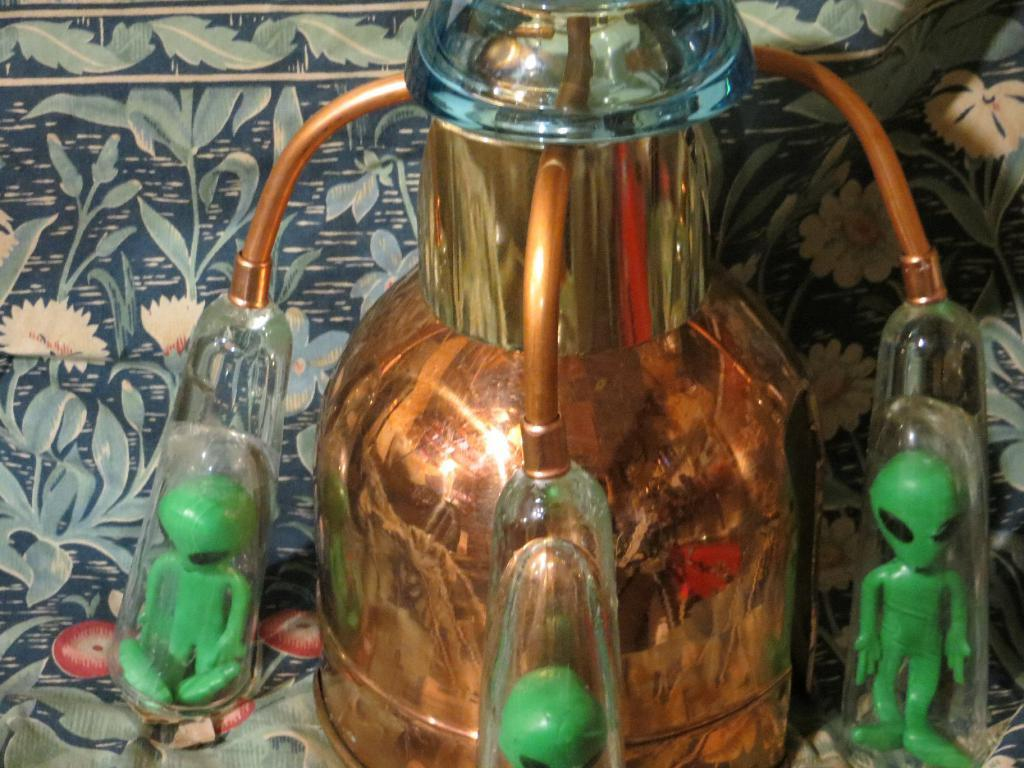What is the color of the object that can be seen in the image? The object in the image is golden-colored. What is inside the golden object? The golden object contains three alien toys. Can you describe the cloth that is present in the image? The cloth has a design of flowers. What type of blade is being used to cut the bone in the image? There is no blade or bone present in the image; it only features a golden object with alien toys and a cloth with a design of flowers. 